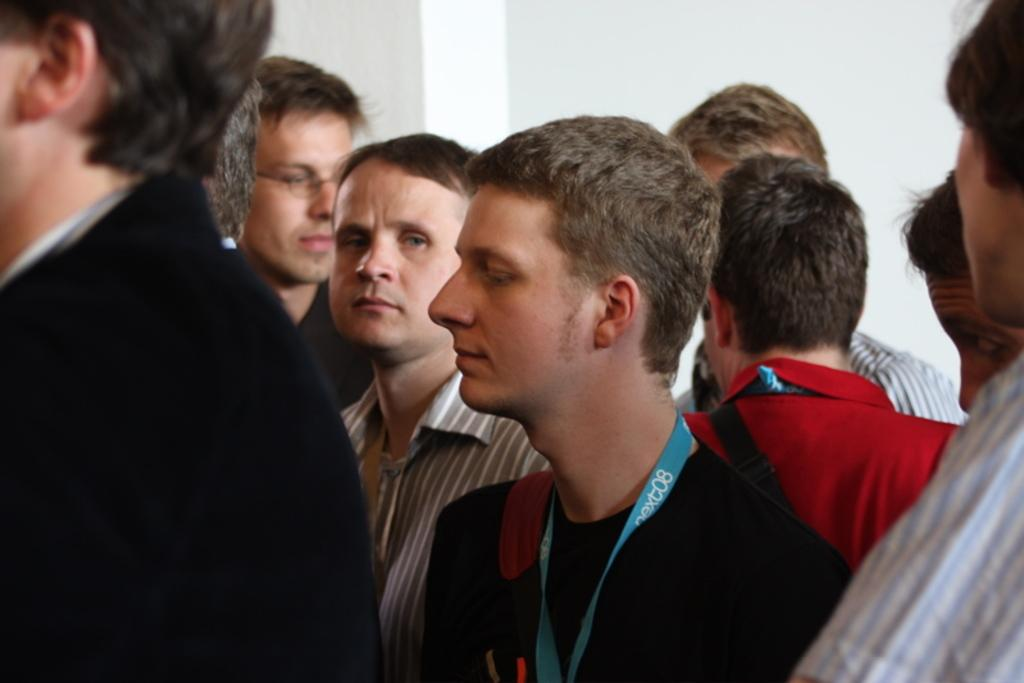What can be seen in the image? There are men standing in the image. What are the men wearing? Three men are wearing bags, and two men are wearing ID card tags. Are all the men fully visible in the image? No, some men are truncated in the image. What is visible in the background of the image? There is a wall in the background of the image. What type of quilt is being offered by the men in the image? There is no quilt present in the image; the men are wearing bags and ID card tags. Can you see any quills being used by the men in the image? There are no quills visible in the image; the men are not holding or using any writing instruments. 